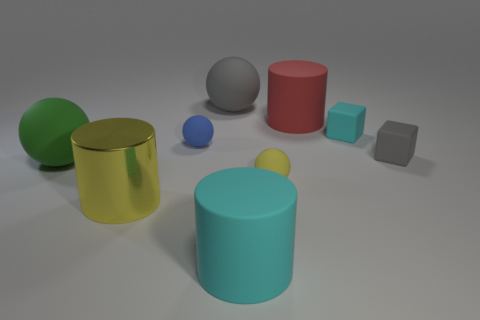Add 1 large cyan rubber cylinders. How many objects exist? 10 Subtract all cylinders. How many objects are left? 6 Subtract all tiny cyan rubber blocks. Subtract all large yellow objects. How many objects are left? 7 Add 4 tiny rubber balls. How many tiny rubber balls are left? 6 Add 3 tiny cyan rubber blocks. How many tiny cyan rubber blocks exist? 4 Subtract 0 purple cubes. How many objects are left? 9 